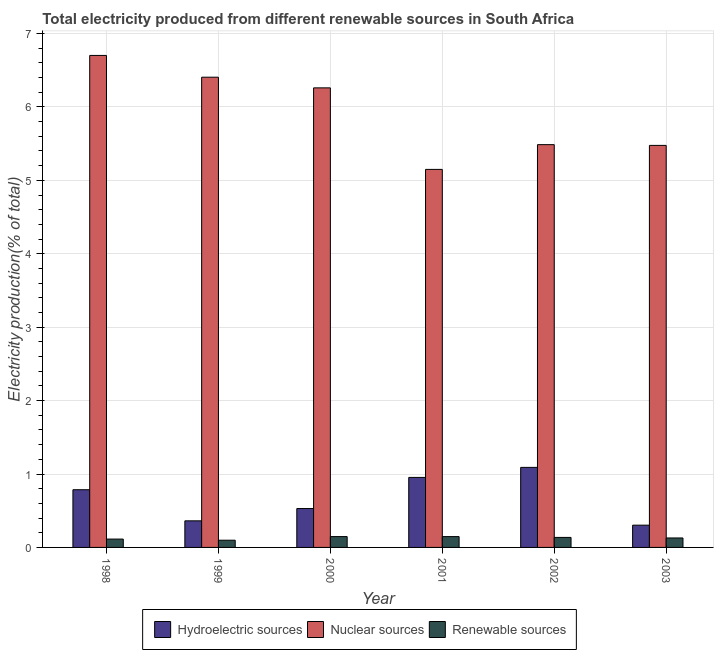Are the number of bars per tick equal to the number of legend labels?
Make the answer very short. Yes. What is the label of the 6th group of bars from the left?
Provide a succinct answer. 2003. In how many cases, is the number of bars for a given year not equal to the number of legend labels?
Provide a succinct answer. 0. What is the percentage of electricity produced by renewable sources in 2000?
Offer a very short reply. 0.15. Across all years, what is the maximum percentage of electricity produced by renewable sources?
Provide a succinct answer. 0.15. Across all years, what is the minimum percentage of electricity produced by hydroelectric sources?
Offer a terse response. 0.3. What is the total percentage of electricity produced by nuclear sources in the graph?
Provide a short and direct response. 35.48. What is the difference between the percentage of electricity produced by nuclear sources in 2001 and that in 2003?
Keep it short and to the point. -0.33. What is the difference between the percentage of electricity produced by hydroelectric sources in 2000 and the percentage of electricity produced by renewable sources in 2003?
Your answer should be compact. 0.23. What is the average percentage of electricity produced by nuclear sources per year?
Offer a terse response. 5.91. What is the ratio of the percentage of electricity produced by nuclear sources in 2000 to that in 2002?
Offer a terse response. 1.14. Is the percentage of electricity produced by nuclear sources in 2001 less than that in 2002?
Give a very brief answer. Yes. Is the difference between the percentage of electricity produced by renewable sources in 2000 and 2003 greater than the difference between the percentage of electricity produced by hydroelectric sources in 2000 and 2003?
Your answer should be very brief. No. What is the difference between the highest and the second highest percentage of electricity produced by renewable sources?
Ensure brevity in your answer.  0. What is the difference between the highest and the lowest percentage of electricity produced by hydroelectric sources?
Offer a terse response. 0.79. In how many years, is the percentage of electricity produced by hydroelectric sources greater than the average percentage of electricity produced by hydroelectric sources taken over all years?
Offer a terse response. 3. Is the sum of the percentage of electricity produced by hydroelectric sources in 1998 and 1999 greater than the maximum percentage of electricity produced by nuclear sources across all years?
Provide a short and direct response. Yes. What does the 2nd bar from the left in 2000 represents?
Provide a short and direct response. Nuclear sources. What does the 1st bar from the right in 2002 represents?
Keep it short and to the point. Renewable sources. How many bars are there?
Ensure brevity in your answer.  18. Are all the bars in the graph horizontal?
Provide a succinct answer. No. How many years are there in the graph?
Offer a terse response. 6. What is the difference between two consecutive major ticks on the Y-axis?
Ensure brevity in your answer.  1. Does the graph contain any zero values?
Offer a terse response. No. Does the graph contain grids?
Offer a very short reply. Yes. Where does the legend appear in the graph?
Ensure brevity in your answer.  Bottom center. How many legend labels are there?
Offer a very short reply. 3. How are the legend labels stacked?
Your response must be concise. Horizontal. What is the title of the graph?
Offer a very short reply. Total electricity produced from different renewable sources in South Africa. Does "Social Protection and Labor" appear as one of the legend labels in the graph?
Ensure brevity in your answer.  No. What is the label or title of the Y-axis?
Give a very brief answer. Electricity production(% of total). What is the Electricity production(% of total) of Hydroelectric sources in 1998?
Give a very brief answer. 0.79. What is the Electricity production(% of total) in Nuclear sources in 1998?
Your answer should be very brief. 6.7. What is the Electricity production(% of total) of Renewable sources in 1998?
Give a very brief answer. 0.11. What is the Electricity production(% of total) in Hydroelectric sources in 1999?
Make the answer very short. 0.36. What is the Electricity production(% of total) of Nuclear sources in 1999?
Your response must be concise. 6.4. What is the Electricity production(% of total) of Renewable sources in 1999?
Your answer should be compact. 0.1. What is the Electricity production(% of total) in Hydroelectric sources in 2000?
Provide a succinct answer. 0.53. What is the Electricity production(% of total) of Nuclear sources in 2000?
Provide a short and direct response. 6.26. What is the Electricity production(% of total) in Renewable sources in 2000?
Make the answer very short. 0.15. What is the Electricity production(% of total) of Hydroelectric sources in 2001?
Provide a succinct answer. 0.95. What is the Electricity production(% of total) of Nuclear sources in 2001?
Your answer should be very brief. 5.15. What is the Electricity production(% of total) of Renewable sources in 2001?
Offer a terse response. 0.15. What is the Electricity production(% of total) of Hydroelectric sources in 2002?
Make the answer very short. 1.09. What is the Electricity production(% of total) in Nuclear sources in 2002?
Keep it short and to the point. 5.49. What is the Electricity production(% of total) in Renewable sources in 2002?
Make the answer very short. 0.14. What is the Electricity production(% of total) of Hydroelectric sources in 2003?
Keep it short and to the point. 0.3. What is the Electricity production(% of total) in Nuclear sources in 2003?
Provide a succinct answer. 5.48. What is the Electricity production(% of total) of Renewable sources in 2003?
Provide a succinct answer. 0.13. Across all years, what is the maximum Electricity production(% of total) in Hydroelectric sources?
Your response must be concise. 1.09. Across all years, what is the maximum Electricity production(% of total) in Nuclear sources?
Keep it short and to the point. 6.7. Across all years, what is the maximum Electricity production(% of total) of Renewable sources?
Provide a succinct answer. 0.15. Across all years, what is the minimum Electricity production(% of total) in Hydroelectric sources?
Your answer should be compact. 0.3. Across all years, what is the minimum Electricity production(% of total) of Nuclear sources?
Keep it short and to the point. 5.15. Across all years, what is the minimum Electricity production(% of total) of Renewable sources?
Give a very brief answer. 0.1. What is the total Electricity production(% of total) of Hydroelectric sources in the graph?
Provide a short and direct response. 4.02. What is the total Electricity production(% of total) in Nuclear sources in the graph?
Your answer should be compact. 35.48. What is the total Electricity production(% of total) of Renewable sources in the graph?
Your answer should be very brief. 0.77. What is the difference between the Electricity production(% of total) of Hydroelectric sources in 1998 and that in 1999?
Offer a very short reply. 0.42. What is the difference between the Electricity production(% of total) in Nuclear sources in 1998 and that in 1999?
Give a very brief answer. 0.3. What is the difference between the Electricity production(% of total) of Renewable sources in 1998 and that in 1999?
Your answer should be very brief. 0.02. What is the difference between the Electricity production(% of total) of Hydroelectric sources in 1998 and that in 2000?
Provide a succinct answer. 0.26. What is the difference between the Electricity production(% of total) of Nuclear sources in 1998 and that in 2000?
Provide a short and direct response. 0.44. What is the difference between the Electricity production(% of total) in Renewable sources in 1998 and that in 2000?
Offer a terse response. -0.03. What is the difference between the Electricity production(% of total) in Hydroelectric sources in 1998 and that in 2001?
Your answer should be very brief. -0.17. What is the difference between the Electricity production(% of total) in Nuclear sources in 1998 and that in 2001?
Offer a very short reply. 1.55. What is the difference between the Electricity production(% of total) of Renewable sources in 1998 and that in 2001?
Offer a terse response. -0.03. What is the difference between the Electricity production(% of total) of Hydroelectric sources in 1998 and that in 2002?
Provide a short and direct response. -0.3. What is the difference between the Electricity production(% of total) in Nuclear sources in 1998 and that in 2002?
Provide a short and direct response. 1.22. What is the difference between the Electricity production(% of total) of Renewable sources in 1998 and that in 2002?
Provide a short and direct response. -0.02. What is the difference between the Electricity production(% of total) in Hydroelectric sources in 1998 and that in 2003?
Your response must be concise. 0.48. What is the difference between the Electricity production(% of total) of Nuclear sources in 1998 and that in 2003?
Your answer should be compact. 1.23. What is the difference between the Electricity production(% of total) of Renewable sources in 1998 and that in 2003?
Keep it short and to the point. -0.01. What is the difference between the Electricity production(% of total) in Hydroelectric sources in 1999 and that in 2000?
Ensure brevity in your answer.  -0.17. What is the difference between the Electricity production(% of total) of Nuclear sources in 1999 and that in 2000?
Provide a succinct answer. 0.15. What is the difference between the Electricity production(% of total) in Renewable sources in 1999 and that in 2000?
Ensure brevity in your answer.  -0.05. What is the difference between the Electricity production(% of total) of Hydroelectric sources in 1999 and that in 2001?
Make the answer very short. -0.59. What is the difference between the Electricity production(% of total) of Nuclear sources in 1999 and that in 2001?
Your answer should be very brief. 1.26. What is the difference between the Electricity production(% of total) of Renewable sources in 1999 and that in 2001?
Keep it short and to the point. -0.05. What is the difference between the Electricity production(% of total) of Hydroelectric sources in 1999 and that in 2002?
Ensure brevity in your answer.  -0.73. What is the difference between the Electricity production(% of total) in Nuclear sources in 1999 and that in 2002?
Make the answer very short. 0.92. What is the difference between the Electricity production(% of total) of Renewable sources in 1999 and that in 2002?
Provide a succinct answer. -0.04. What is the difference between the Electricity production(% of total) in Hydroelectric sources in 1999 and that in 2003?
Ensure brevity in your answer.  0.06. What is the difference between the Electricity production(% of total) of Nuclear sources in 1999 and that in 2003?
Your answer should be compact. 0.93. What is the difference between the Electricity production(% of total) of Renewable sources in 1999 and that in 2003?
Make the answer very short. -0.03. What is the difference between the Electricity production(% of total) of Hydroelectric sources in 2000 and that in 2001?
Offer a very short reply. -0.42. What is the difference between the Electricity production(% of total) of Nuclear sources in 2000 and that in 2001?
Give a very brief answer. 1.11. What is the difference between the Electricity production(% of total) of Hydroelectric sources in 2000 and that in 2002?
Offer a very short reply. -0.56. What is the difference between the Electricity production(% of total) of Nuclear sources in 2000 and that in 2002?
Offer a terse response. 0.77. What is the difference between the Electricity production(% of total) of Renewable sources in 2000 and that in 2002?
Provide a succinct answer. 0.01. What is the difference between the Electricity production(% of total) of Hydroelectric sources in 2000 and that in 2003?
Give a very brief answer. 0.23. What is the difference between the Electricity production(% of total) of Nuclear sources in 2000 and that in 2003?
Your answer should be compact. 0.78. What is the difference between the Electricity production(% of total) of Renewable sources in 2000 and that in 2003?
Make the answer very short. 0.02. What is the difference between the Electricity production(% of total) in Hydroelectric sources in 2001 and that in 2002?
Provide a short and direct response. -0.14. What is the difference between the Electricity production(% of total) of Nuclear sources in 2001 and that in 2002?
Give a very brief answer. -0.34. What is the difference between the Electricity production(% of total) in Renewable sources in 2001 and that in 2002?
Offer a terse response. 0.01. What is the difference between the Electricity production(% of total) in Hydroelectric sources in 2001 and that in 2003?
Provide a short and direct response. 0.65. What is the difference between the Electricity production(% of total) of Nuclear sources in 2001 and that in 2003?
Offer a very short reply. -0.33. What is the difference between the Electricity production(% of total) of Renewable sources in 2001 and that in 2003?
Provide a succinct answer. 0.02. What is the difference between the Electricity production(% of total) of Hydroelectric sources in 2002 and that in 2003?
Offer a very short reply. 0.79. What is the difference between the Electricity production(% of total) in Nuclear sources in 2002 and that in 2003?
Give a very brief answer. 0.01. What is the difference between the Electricity production(% of total) in Renewable sources in 2002 and that in 2003?
Provide a short and direct response. 0.01. What is the difference between the Electricity production(% of total) in Hydroelectric sources in 1998 and the Electricity production(% of total) in Nuclear sources in 1999?
Ensure brevity in your answer.  -5.62. What is the difference between the Electricity production(% of total) in Hydroelectric sources in 1998 and the Electricity production(% of total) in Renewable sources in 1999?
Ensure brevity in your answer.  0.69. What is the difference between the Electricity production(% of total) in Nuclear sources in 1998 and the Electricity production(% of total) in Renewable sources in 1999?
Provide a short and direct response. 6.6. What is the difference between the Electricity production(% of total) in Hydroelectric sources in 1998 and the Electricity production(% of total) in Nuclear sources in 2000?
Ensure brevity in your answer.  -5.47. What is the difference between the Electricity production(% of total) in Hydroelectric sources in 1998 and the Electricity production(% of total) in Renewable sources in 2000?
Your answer should be very brief. 0.64. What is the difference between the Electricity production(% of total) of Nuclear sources in 1998 and the Electricity production(% of total) of Renewable sources in 2000?
Your answer should be compact. 6.55. What is the difference between the Electricity production(% of total) in Hydroelectric sources in 1998 and the Electricity production(% of total) in Nuclear sources in 2001?
Offer a very short reply. -4.36. What is the difference between the Electricity production(% of total) in Hydroelectric sources in 1998 and the Electricity production(% of total) in Renewable sources in 2001?
Provide a succinct answer. 0.64. What is the difference between the Electricity production(% of total) of Nuclear sources in 1998 and the Electricity production(% of total) of Renewable sources in 2001?
Provide a short and direct response. 6.55. What is the difference between the Electricity production(% of total) in Hydroelectric sources in 1998 and the Electricity production(% of total) in Nuclear sources in 2002?
Ensure brevity in your answer.  -4.7. What is the difference between the Electricity production(% of total) of Hydroelectric sources in 1998 and the Electricity production(% of total) of Renewable sources in 2002?
Your response must be concise. 0.65. What is the difference between the Electricity production(% of total) in Nuclear sources in 1998 and the Electricity production(% of total) in Renewable sources in 2002?
Offer a terse response. 6.57. What is the difference between the Electricity production(% of total) in Hydroelectric sources in 1998 and the Electricity production(% of total) in Nuclear sources in 2003?
Ensure brevity in your answer.  -4.69. What is the difference between the Electricity production(% of total) in Hydroelectric sources in 1998 and the Electricity production(% of total) in Renewable sources in 2003?
Provide a short and direct response. 0.66. What is the difference between the Electricity production(% of total) in Nuclear sources in 1998 and the Electricity production(% of total) in Renewable sources in 2003?
Offer a terse response. 6.57. What is the difference between the Electricity production(% of total) of Hydroelectric sources in 1999 and the Electricity production(% of total) of Nuclear sources in 2000?
Make the answer very short. -5.9. What is the difference between the Electricity production(% of total) of Hydroelectric sources in 1999 and the Electricity production(% of total) of Renewable sources in 2000?
Ensure brevity in your answer.  0.21. What is the difference between the Electricity production(% of total) in Nuclear sources in 1999 and the Electricity production(% of total) in Renewable sources in 2000?
Provide a succinct answer. 6.26. What is the difference between the Electricity production(% of total) in Hydroelectric sources in 1999 and the Electricity production(% of total) in Nuclear sources in 2001?
Your answer should be very brief. -4.79. What is the difference between the Electricity production(% of total) of Hydroelectric sources in 1999 and the Electricity production(% of total) of Renewable sources in 2001?
Provide a succinct answer. 0.21. What is the difference between the Electricity production(% of total) of Nuclear sources in 1999 and the Electricity production(% of total) of Renewable sources in 2001?
Give a very brief answer. 6.26. What is the difference between the Electricity production(% of total) of Hydroelectric sources in 1999 and the Electricity production(% of total) of Nuclear sources in 2002?
Your answer should be very brief. -5.12. What is the difference between the Electricity production(% of total) of Hydroelectric sources in 1999 and the Electricity production(% of total) of Renewable sources in 2002?
Provide a succinct answer. 0.23. What is the difference between the Electricity production(% of total) of Nuclear sources in 1999 and the Electricity production(% of total) of Renewable sources in 2002?
Make the answer very short. 6.27. What is the difference between the Electricity production(% of total) of Hydroelectric sources in 1999 and the Electricity production(% of total) of Nuclear sources in 2003?
Offer a terse response. -5.11. What is the difference between the Electricity production(% of total) in Hydroelectric sources in 1999 and the Electricity production(% of total) in Renewable sources in 2003?
Your response must be concise. 0.23. What is the difference between the Electricity production(% of total) in Nuclear sources in 1999 and the Electricity production(% of total) in Renewable sources in 2003?
Keep it short and to the point. 6.28. What is the difference between the Electricity production(% of total) of Hydroelectric sources in 2000 and the Electricity production(% of total) of Nuclear sources in 2001?
Keep it short and to the point. -4.62. What is the difference between the Electricity production(% of total) in Hydroelectric sources in 2000 and the Electricity production(% of total) in Renewable sources in 2001?
Offer a terse response. 0.38. What is the difference between the Electricity production(% of total) in Nuclear sources in 2000 and the Electricity production(% of total) in Renewable sources in 2001?
Make the answer very short. 6.11. What is the difference between the Electricity production(% of total) of Hydroelectric sources in 2000 and the Electricity production(% of total) of Nuclear sources in 2002?
Give a very brief answer. -4.96. What is the difference between the Electricity production(% of total) of Hydroelectric sources in 2000 and the Electricity production(% of total) of Renewable sources in 2002?
Keep it short and to the point. 0.39. What is the difference between the Electricity production(% of total) in Nuclear sources in 2000 and the Electricity production(% of total) in Renewable sources in 2002?
Provide a succinct answer. 6.12. What is the difference between the Electricity production(% of total) of Hydroelectric sources in 2000 and the Electricity production(% of total) of Nuclear sources in 2003?
Your answer should be compact. -4.95. What is the difference between the Electricity production(% of total) of Hydroelectric sources in 2000 and the Electricity production(% of total) of Renewable sources in 2003?
Keep it short and to the point. 0.4. What is the difference between the Electricity production(% of total) of Nuclear sources in 2000 and the Electricity production(% of total) of Renewable sources in 2003?
Provide a short and direct response. 6.13. What is the difference between the Electricity production(% of total) of Hydroelectric sources in 2001 and the Electricity production(% of total) of Nuclear sources in 2002?
Ensure brevity in your answer.  -4.53. What is the difference between the Electricity production(% of total) in Hydroelectric sources in 2001 and the Electricity production(% of total) in Renewable sources in 2002?
Make the answer very short. 0.82. What is the difference between the Electricity production(% of total) in Nuclear sources in 2001 and the Electricity production(% of total) in Renewable sources in 2002?
Your response must be concise. 5.01. What is the difference between the Electricity production(% of total) in Hydroelectric sources in 2001 and the Electricity production(% of total) in Nuclear sources in 2003?
Your answer should be compact. -4.52. What is the difference between the Electricity production(% of total) of Hydroelectric sources in 2001 and the Electricity production(% of total) of Renewable sources in 2003?
Offer a terse response. 0.82. What is the difference between the Electricity production(% of total) in Nuclear sources in 2001 and the Electricity production(% of total) in Renewable sources in 2003?
Make the answer very short. 5.02. What is the difference between the Electricity production(% of total) in Hydroelectric sources in 2002 and the Electricity production(% of total) in Nuclear sources in 2003?
Keep it short and to the point. -4.39. What is the difference between the Electricity production(% of total) of Hydroelectric sources in 2002 and the Electricity production(% of total) of Renewable sources in 2003?
Provide a succinct answer. 0.96. What is the difference between the Electricity production(% of total) of Nuclear sources in 2002 and the Electricity production(% of total) of Renewable sources in 2003?
Provide a succinct answer. 5.36. What is the average Electricity production(% of total) in Hydroelectric sources per year?
Give a very brief answer. 0.67. What is the average Electricity production(% of total) of Nuclear sources per year?
Your response must be concise. 5.91. What is the average Electricity production(% of total) in Renewable sources per year?
Offer a very short reply. 0.13. In the year 1998, what is the difference between the Electricity production(% of total) in Hydroelectric sources and Electricity production(% of total) in Nuclear sources?
Your answer should be very brief. -5.92. In the year 1998, what is the difference between the Electricity production(% of total) of Hydroelectric sources and Electricity production(% of total) of Renewable sources?
Offer a very short reply. 0.67. In the year 1998, what is the difference between the Electricity production(% of total) in Nuclear sources and Electricity production(% of total) in Renewable sources?
Your response must be concise. 6.59. In the year 1999, what is the difference between the Electricity production(% of total) of Hydroelectric sources and Electricity production(% of total) of Nuclear sources?
Offer a very short reply. -6.04. In the year 1999, what is the difference between the Electricity production(% of total) of Hydroelectric sources and Electricity production(% of total) of Renewable sources?
Your answer should be compact. 0.26. In the year 1999, what is the difference between the Electricity production(% of total) in Nuclear sources and Electricity production(% of total) in Renewable sources?
Offer a very short reply. 6.31. In the year 2000, what is the difference between the Electricity production(% of total) of Hydroelectric sources and Electricity production(% of total) of Nuclear sources?
Keep it short and to the point. -5.73. In the year 2000, what is the difference between the Electricity production(% of total) of Hydroelectric sources and Electricity production(% of total) of Renewable sources?
Offer a very short reply. 0.38. In the year 2000, what is the difference between the Electricity production(% of total) of Nuclear sources and Electricity production(% of total) of Renewable sources?
Your response must be concise. 6.11. In the year 2001, what is the difference between the Electricity production(% of total) of Hydroelectric sources and Electricity production(% of total) of Nuclear sources?
Offer a very short reply. -4.2. In the year 2001, what is the difference between the Electricity production(% of total) in Hydroelectric sources and Electricity production(% of total) in Renewable sources?
Your response must be concise. 0.81. In the year 2001, what is the difference between the Electricity production(% of total) in Nuclear sources and Electricity production(% of total) in Renewable sources?
Your answer should be compact. 5. In the year 2002, what is the difference between the Electricity production(% of total) in Hydroelectric sources and Electricity production(% of total) in Nuclear sources?
Offer a terse response. -4.4. In the year 2002, what is the difference between the Electricity production(% of total) of Hydroelectric sources and Electricity production(% of total) of Renewable sources?
Make the answer very short. 0.95. In the year 2002, what is the difference between the Electricity production(% of total) of Nuclear sources and Electricity production(% of total) of Renewable sources?
Make the answer very short. 5.35. In the year 2003, what is the difference between the Electricity production(% of total) in Hydroelectric sources and Electricity production(% of total) in Nuclear sources?
Provide a succinct answer. -5.17. In the year 2003, what is the difference between the Electricity production(% of total) in Hydroelectric sources and Electricity production(% of total) in Renewable sources?
Make the answer very short. 0.17. In the year 2003, what is the difference between the Electricity production(% of total) of Nuclear sources and Electricity production(% of total) of Renewable sources?
Your answer should be compact. 5.35. What is the ratio of the Electricity production(% of total) of Hydroelectric sources in 1998 to that in 1999?
Give a very brief answer. 2.17. What is the ratio of the Electricity production(% of total) in Nuclear sources in 1998 to that in 1999?
Provide a short and direct response. 1.05. What is the ratio of the Electricity production(% of total) in Renewable sources in 1998 to that in 1999?
Offer a terse response. 1.16. What is the ratio of the Electricity production(% of total) in Hydroelectric sources in 1998 to that in 2000?
Your response must be concise. 1.48. What is the ratio of the Electricity production(% of total) of Nuclear sources in 1998 to that in 2000?
Ensure brevity in your answer.  1.07. What is the ratio of the Electricity production(% of total) in Renewable sources in 1998 to that in 2000?
Offer a terse response. 0.77. What is the ratio of the Electricity production(% of total) of Hydroelectric sources in 1998 to that in 2001?
Provide a short and direct response. 0.82. What is the ratio of the Electricity production(% of total) in Nuclear sources in 1998 to that in 2001?
Provide a short and direct response. 1.3. What is the ratio of the Electricity production(% of total) in Renewable sources in 1998 to that in 2001?
Your response must be concise. 0.77. What is the ratio of the Electricity production(% of total) of Hydroelectric sources in 1998 to that in 2002?
Give a very brief answer. 0.72. What is the ratio of the Electricity production(% of total) in Nuclear sources in 1998 to that in 2002?
Offer a very short reply. 1.22. What is the ratio of the Electricity production(% of total) in Renewable sources in 1998 to that in 2002?
Offer a very short reply. 0.83. What is the ratio of the Electricity production(% of total) in Hydroelectric sources in 1998 to that in 2003?
Ensure brevity in your answer.  2.59. What is the ratio of the Electricity production(% of total) of Nuclear sources in 1998 to that in 2003?
Your response must be concise. 1.22. What is the ratio of the Electricity production(% of total) of Renewable sources in 1998 to that in 2003?
Provide a succinct answer. 0.88. What is the ratio of the Electricity production(% of total) in Hydroelectric sources in 1999 to that in 2000?
Your response must be concise. 0.68. What is the ratio of the Electricity production(% of total) of Nuclear sources in 1999 to that in 2000?
Provide a short and direct response. 1.02. What is the ratio of the Electricity production(% of total) of Renewable sources in 1999 to that in 2000?
Offer a very short reply. 0.67. What is the ratio of the Electricity production(% of total) of Hydroelectric sources in 1999 to that in 2001?
Offer a very short reply. 0.38. What is the ratio of the Electricity production(% of total) in Nuclear sources in 1999 to that in 2001?
Provide a succinct answer. 1.24. What is the ratio of the Electricity production(% of total) of Renewable sources in 1999 to that in 2001?
Offer a very short reply. 0.67. What is the ratio of the Electricity production(% of total) of Hydroelectric sources in 1999 to that in 2002?
Offer a very short reply. 0.33. What is the ratio of the Electricity production(% of total) of Nuclear sources in 1999 to that in 2002?
Your response must be concise. 1.17. What is the ratio of the Electricity production(% of total) in Renewable sources in 1999 to that in 2002?
Offer a terse response. 0.72. What is the ratio of the Electricity production(% of total) in Hydroelectric sources in 1999 to that in 2003?
Ensure brevity in your answer.  1.2. What is the ratio of the Electricity production(% of total) of Nuclear sources in 1999 to that in 2003?
Offer a terse response. 1.17. What is the ratio of the Electricity production(% of total) in Renewable sources in 1999 to that in 2003?
Provide a short and direct response. 0.76. What is the ratio of the Electricity production(% of total) of Hydroelectric sources in 2000 to that in 2001?
Your answer should be compact. 0.56. What is the ratio of the Electricity production(% of total) of Nuclear sources in 2000 to that in 2001?
Your response must be concise. 1.22. What is the ratio of the Electricity production(% of total) of Hydroelectric sources in 2000 to that in 2002?
Provide a succinct answer. 0.49. What is the ratio of the Electricity production(% of total) of Nuclear sources in 2000 to that in 2002?
Offer a very short reply. 1.14. What is the ratio of the Electricity production(% of total) of Renewable sources in 2000 to that in 2002?
Provide a short and direct response. 1.08. What is the ratio of the Electricity production(% of total) in Hydroelectric sources in 2000 to that in 2003?
Provide a succinct answer. 1.75. What is the ratio of the Electricity production(% of total) in Nuclear sources in 2000 to that in 2003?
Your answer should be compact. 1.14. What is the ratio of the Electricity production(% of total) in Renewable sources in 2000 to that in 2003?
Give a very brief answer. 1.15. What is the ratio of the Electricity production(% of total) of Hydroelectric sources in 2001 to that in 2002?
Your answer should be compact. 0.87. What is the ratio of the Electricity production(% of total) of Nuclear sources in 2001 to that in 2002?
Your answer should be compact. 0.94. What is the ratio of the Electricity production(% of total) of Renewable sources in 2001 to that in 2002?
Your answer should be compact. 1.08. What is the ratio of the Electricity production(% of total) in Hydroelectric sources in 2001 to that in 2003?
Provide a short and direct response. 3.15. What is the ratio of the Electricity production(% of total) of Nuclear sources in 2001 to that in 2003?
Provide a succinct answer. 0.94. What is the ratio of the Electricity production(% of total) in Renewable sources in 2001 to that in 2003?
Provide a short and direct response. 1.14. What is the ratio of the Electricity production(% of total) in Hydroelectric sources in 2002 to that in 2003?
Your answer should be very brief. 3.6. What is the ratio of the Electricity production(% of total) in Renewable sources in 2002 to that in 2003?
Give a very brief answer. 1.06. What is the difference between the highest and the second highest Electricity production(% of total) of Hydroelectric sources?
Offer a very short reply. 0.14. What is the difference between the highest and the second highest Electricity production(% of total) in Nuclear sources?
Your response must be concise. 0.3. What is the difference between the highest and the lowest Electricity production(% of total) of Hydroelectric sources?
Your response must be concise. 0.79. What is the difference between the highest and the lowest Electricity production(% of total) of Nuclear sources?
Make the answer very short. 1.55. What is the difference between the highest and the lowest Electricity production(% of total) in Renewable sources?
Make the answer very short. 0.05. 